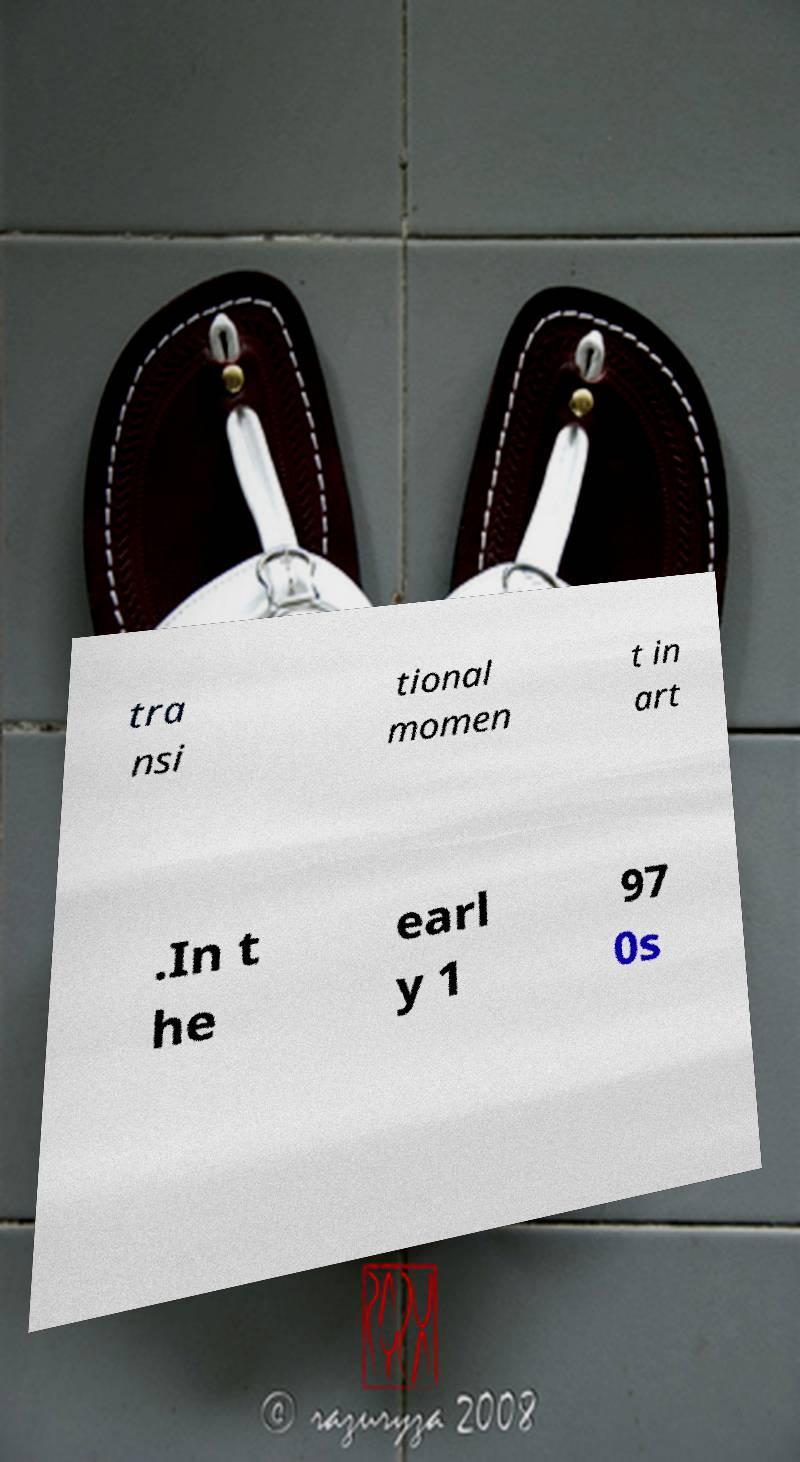For documentation purposes, I need the text within this image transcribed. Could you provide that? tra nsi tional momen t in art .In t he earl y 1 97 0s 